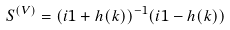Convert formula to latex. <formula><loc_0><loc_0><loc_500><loc_500>S ^ { ( V ) } = ( i { 1 } + h ( k ) ) ^ { - 1 } ( i { 1 } - h ( k ) )</formula> 